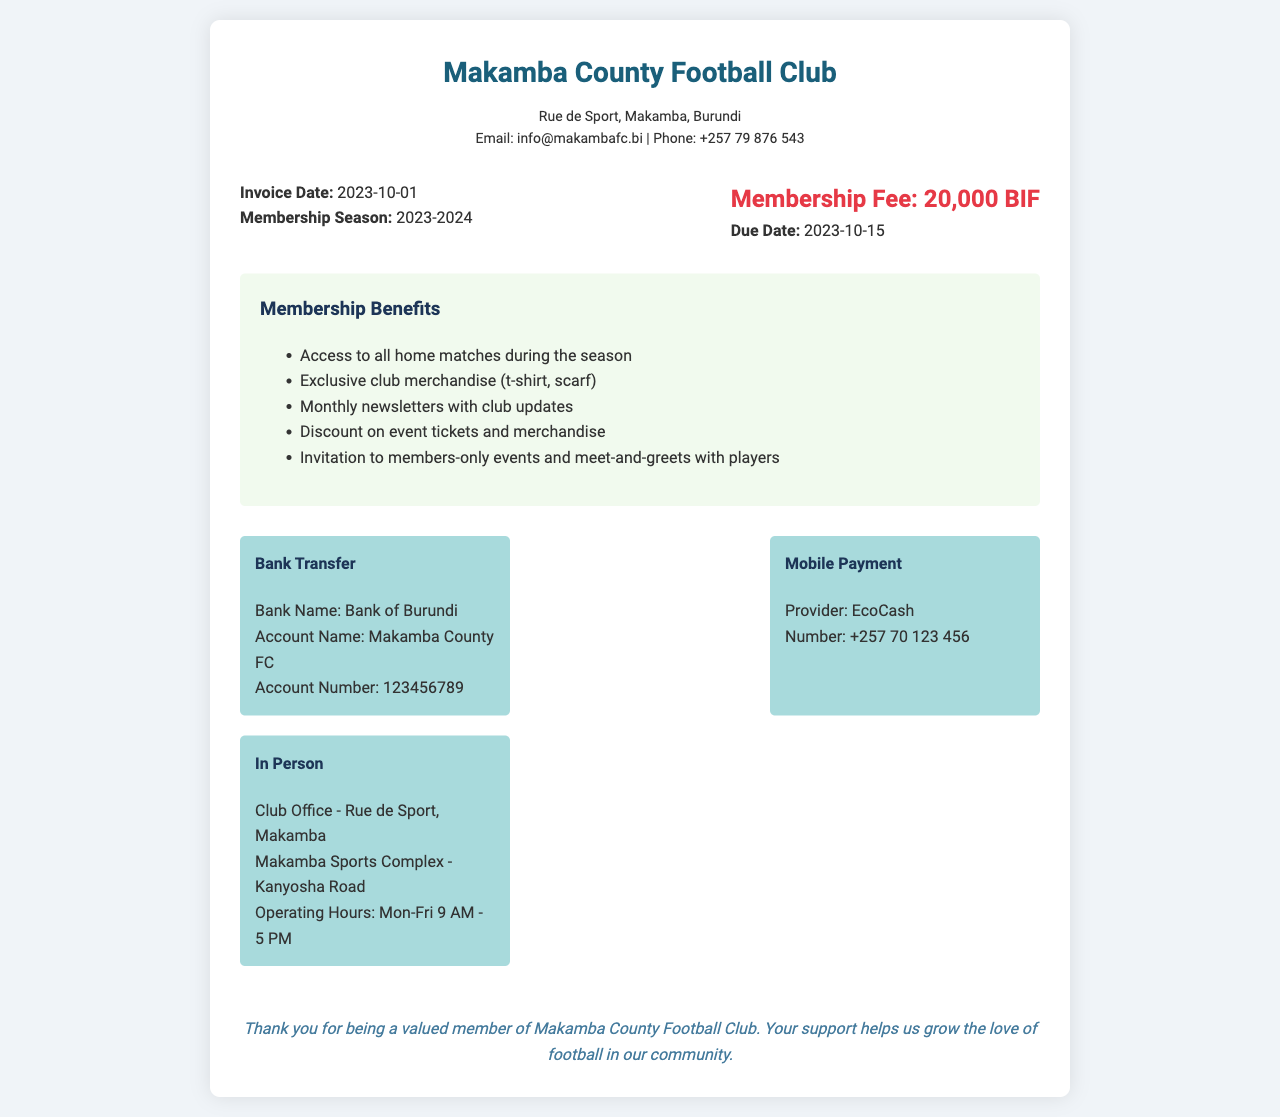What is the club name? The club name is prominently displayed at the top of the document.
Answer: Makamba County Football Club What is the membership fee? The membership fee is stated in the invoice details section.
Answer: 20,000 BIF What is the invoice date? The invoice date is indicated in the invoice details section.
Answer: 2023-10-01 What are the membership benefits? The document lists specific benefits in the benefits list section.
Answer: Access to all home matches during the season What is the due date for the membership fee? The due date is specified in the invoice details section.
Answer: 2023-10-15 How many payment methods are provided? The document lists different payment methods in the payment methods section.
Answer: 3 What payment method can be used for mobile transfers? The document specifies a method for mobile payment.
Answer: EcoCash Where is the club office located? The club office address is mentioned in the payment methods section.
Answer: Rue de Sport, Makamba What benefit includes discounts? Discounts are mentioned in the benefits list section.
Answer: Discount on event tickets and merchandise 